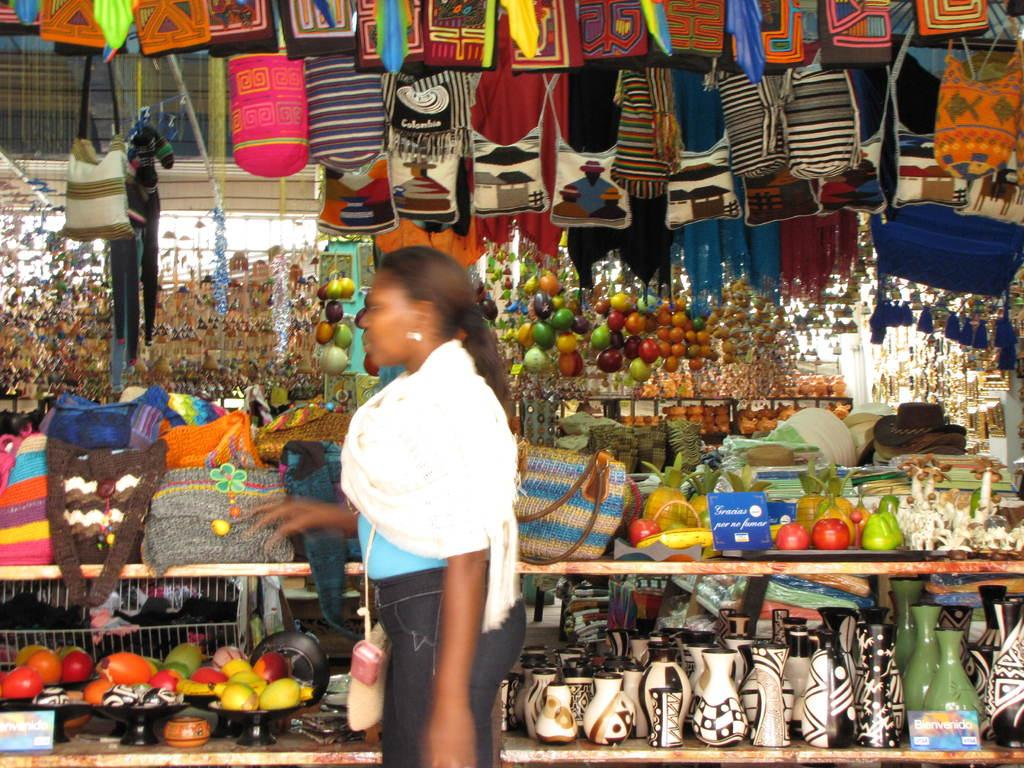What is the main subject of the image? There is a person standing in the center of the image. What can be seen in the background of the image? In the background, there are handbags, baskets, bells, pots, and jars. Can you describe the other objects in the background? There are a few other objects in the background, but their specific details are not mentioned in the provided facts. What type of wristwatch is the person wearing in the image? There is no wristwatch visible in the image. How does the wind affect the objects in the image? The provided facts do not mention any wind or its effects on the objects in the image. 